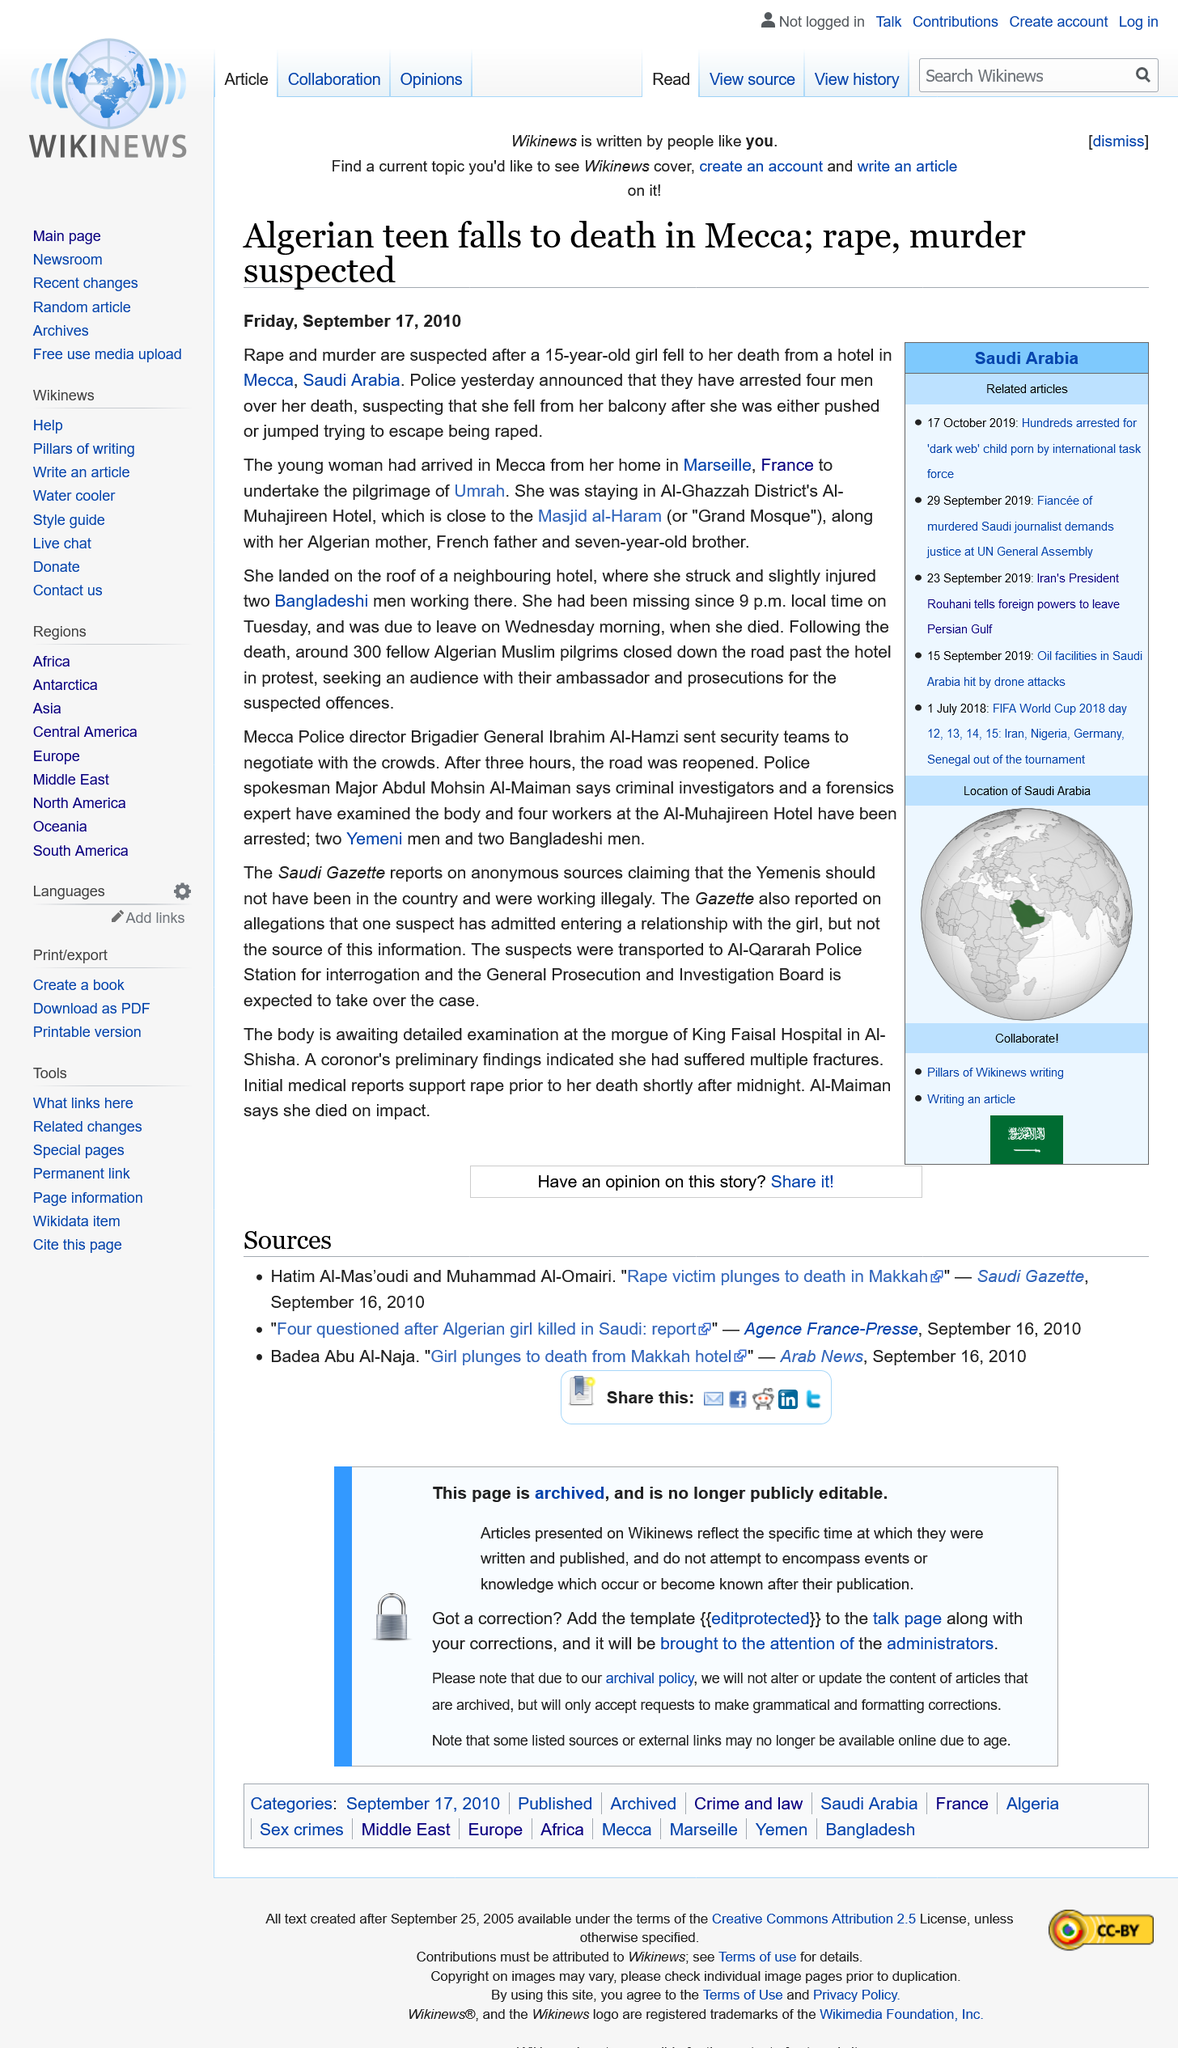Identify some key points in this picture. The article titled "Algerian teen falls to death in Mecca: rape, murder suspected" was published on Friday, September 17, 2010. The event took place in Mecca, as declared by the speaker. The suspected cause of death for an Algerian teenager is rape and murder. 